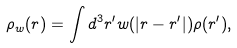<formula> <loc_0><loc_0><loc_500><loc_500>\rho _ { w } ( { r } ) = \int d ^ { 3 } { r ^ { \prime } } w ( | { r } - { r ^ { \prime } } | ) \rho ( { r ^ { \prime } } ) ,</formula> 